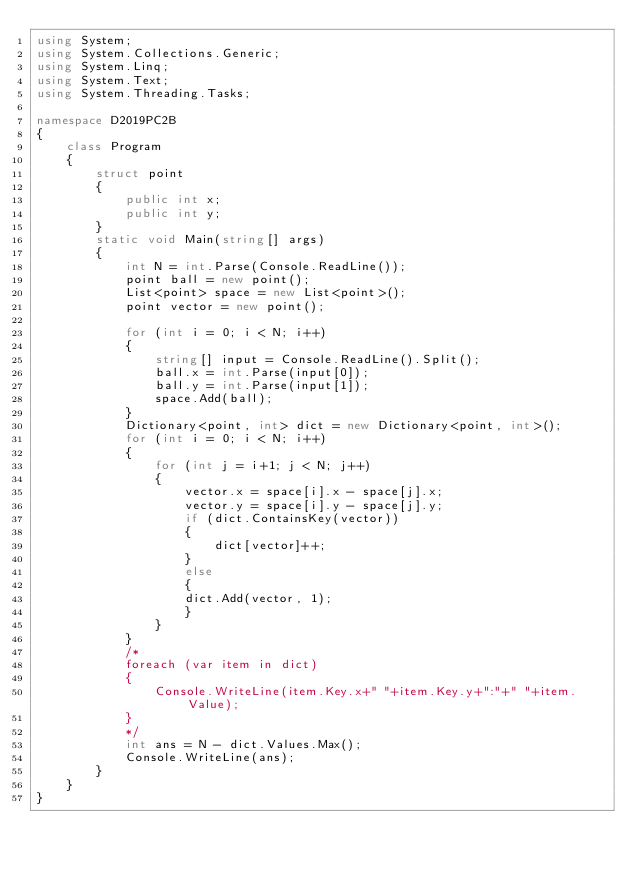<code> <loc_0><loc_0><loc_500><loc_500><_C#_>using System;
using System.Collections.Generic;
using System.Linq;
using System.Text;
using System.Threading.Tasks;

namespace D2019PC2B
{
    class Program
    {
        struct point
        {
            public int x;
            public int y;
        }
        static void Main(string[] args)
        {
            int N = int.Parse(Console.ReadLine());
            point ball = new point();
            List<point> space = new List<point>();
            point vector = new point();

            for (int i = 0; i < N; i++)
            {
                string[] input = Console.ReadLine().Split();
                ball.x = int.Parse(input[0]);
                ball.y = int.Parse(input[1]);
                space.Add(ball);
            }
            Dictionary<point, int> dict = new Dictionary<point, int>();
            for (int i = 0; i < N; i++)
            {
                for (int j = i+1; j < N; j++)
                {
                    vector.x = space[i].x - space[j].x;
                    vector.y = space[i].y - space[j].y;
                    if (dict.ContainsKey(vector))
                    {
                        dict[vector]++;
                    }
                    else
                    {
                    dict.Add(vector, 1);
                    }
                }
            }
            /*
            foreach (var item in dict)
            {
                Console.WriteLine(item.Key.x+" "+item.Key.y+":"+" "+item.Value);
            }
            */
            int ans = N - dict.Values.Max();
            Console.WriteLine(ans);
        }
    }
}
</code> 